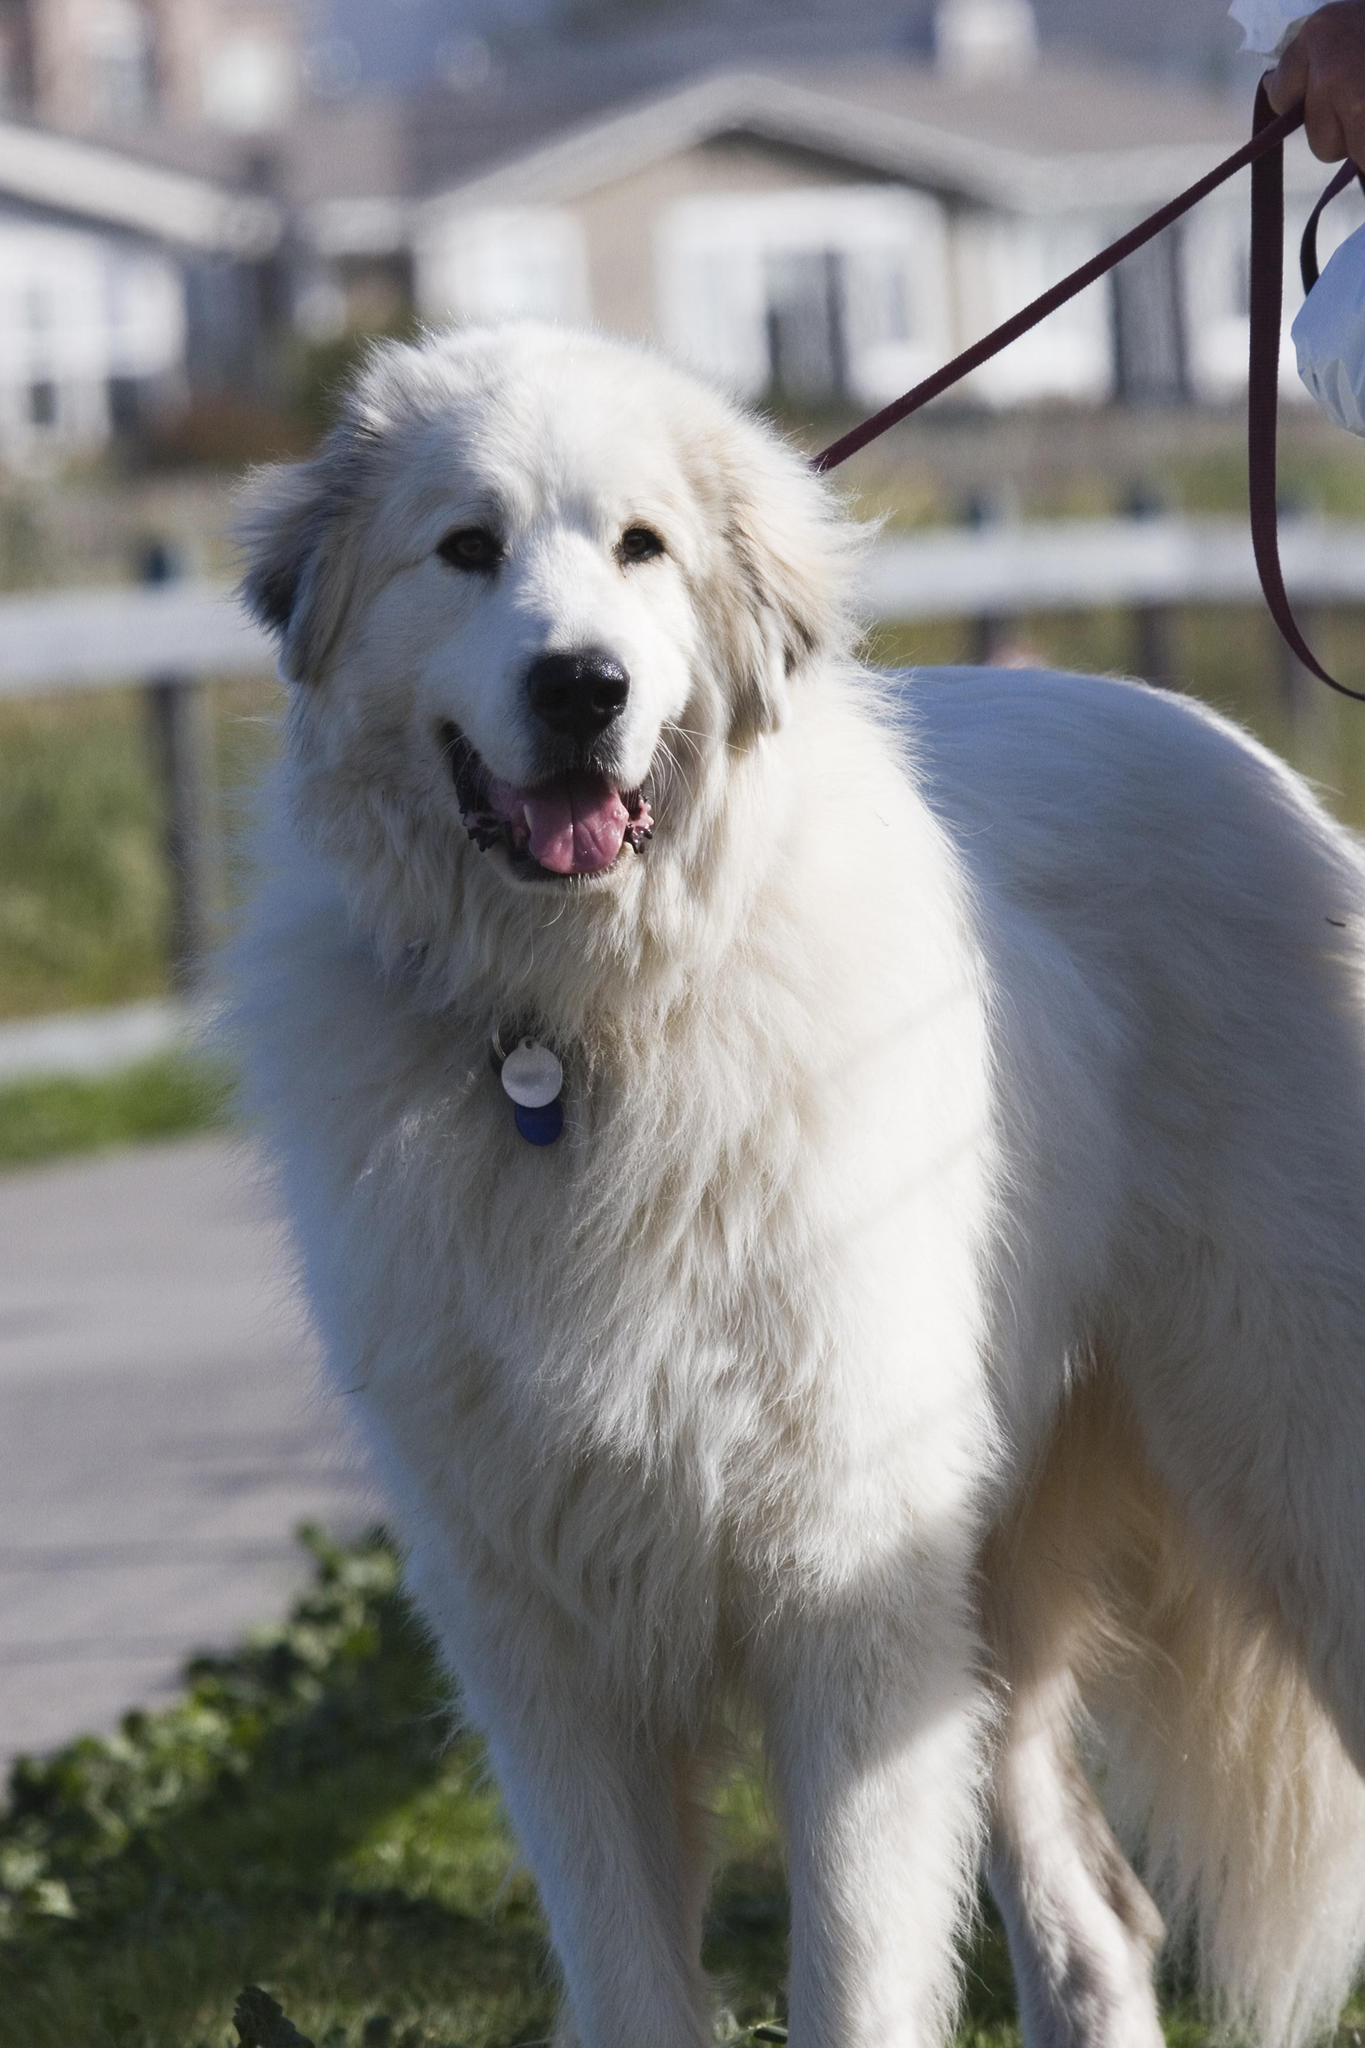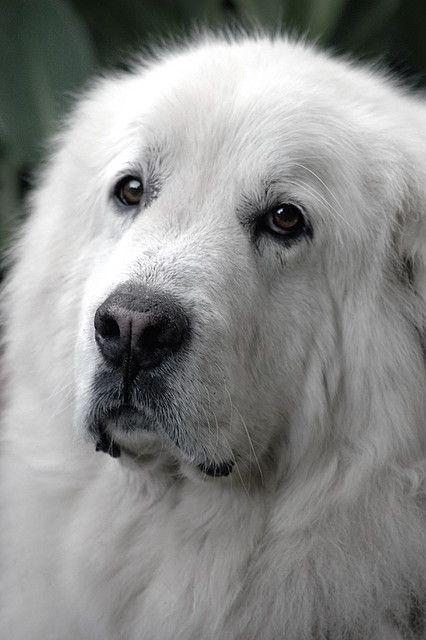The first image is the image on the left, the second image is the image on the right. Assess this claim about the two images: "The dog on the right image is of a young puppy.". Correct or not? Answer yes or no. No. 